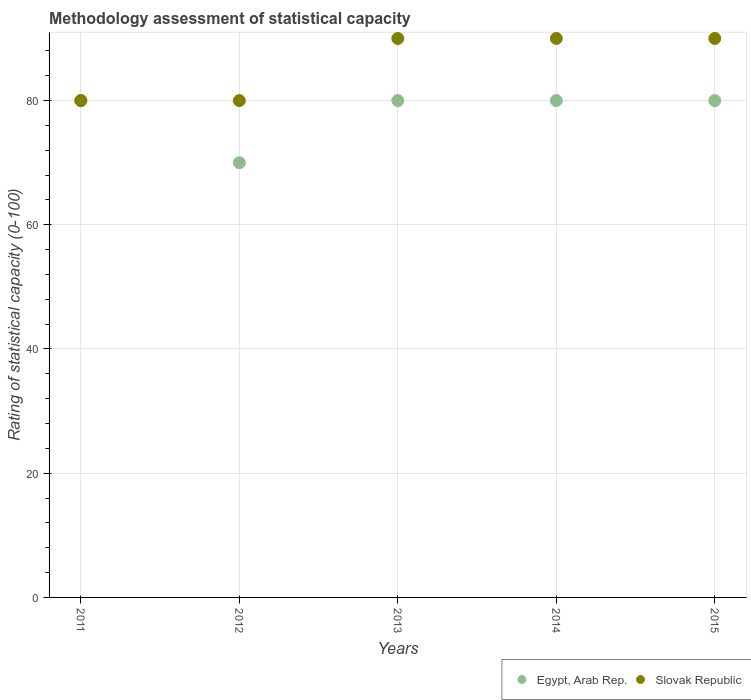What is the rating of statistical capacity in Egypt, Arab Rep. in 2014?
Keep it short and to the point. 80. Across all years, what is the maximum rating of statistical capacity in Egypt, Arab Rep.?
Your answer should be very brief. 80. Across all years, what is the minimum rating of statistical capacity in Slovak Republic?
Give a very brief answer. 80. In which year was the rating of statistical capacity in Egypt, Arab Rep. minimum?
Your response must be concise. 2012. What is the total rating of statistical capacity in Egypt, Arab Rep. in the graph?
Provide a succinct answer. 390. What is the difference between the rating of statistical capacity in Slovak Republic in 2015 and the rating of statistical capacity in Egypt, Arab Rep. in 2013?
Your answer should be very brief. 10. What is the ratio of the rating of statistical capacity in Slovak Republic in 2011 to that in 2015?
Your response must be concise. 0.89. What is the difference between the highest and the second highest rating of statistical capacity in Egypt, Arab Rep.?
Ensure brevity in your answer.  0. What is the difference between the highest and the lowest rating of statistical capacity in Egypt, Arab Rep.?
Your response must be concise. 10. Is the sum of the rating of statistical capacity in Egypt, Arab Rep. in 2013 and 2015 greater than the maximum rating of statistical capacity in Slovak Republic across all years?
Keep it short and to the point. Yes. Does the rating of statistical capacity in Slovak Republic monotonically increase over the years?
Your answer should be very brief. No. What is the difference between two consecutive major ticks on the Y-axis?
Provide a short and direct response. 20. Are the values on the major ticks of Y-axis written in scientific E-notation?
Provide a short and direct response. No. How many legend labels are there?
Your answer should be very brief. 2. How are the legend labels stacked?
Offer a very short reply. Horizontal. What is the title of the graph?
Provide a short and direct response. Methodology assessment of statistical capacity. What is the label or title of the X-axis?
Your answer should be compact. Years. What is the label or title of the Y-axis?
Make the answer very short. Rating of statistical capacity (0-100). What is the Rating of statistical capacity (0-100) of Egypt, Arab Rep. in 2011?
Your answer should be compact. 80. What is the Rating of statistical capacity (0-100) in Slovak Republic in 2011?
Your answer should be very brief. 80. What is the Rating of statistical capacity (0-100) of Egypt, Arab Rep. in 2012?
Provide a succinct answer. 70. What is the Rating of statistical capacity (0-100) in Slovak Republic in 2013?
Your answer should be compact. 90. What is the Rating of statistical capacity (0-100) in Slovak Republic in 2014?
Your response must be concise. 90. Across all years, what is the maximum Rating of statistical capacity (0-100) of Egypt, Arab Rep.?
Offer a terse response. 80. Across all years, what is the minimum Rating of statistical capacity (0-100) in Egypt, Arab Rep.?
Provide a succinct answer. 70. What is the total Rating of statistical capacity (0-100) of Egypt, Arab Rep. in the graph?
Ensure brevity in your answer.  390. What is the total Rating of statistical capacity (0-100) in Slovak Republic in the graph?
Your answer should be compact. 430. What is the difference between the Rating of statistical capacity (0-100) of Egypt, Arab Rep. in 2011 and that in 2013?
Give a very brief answer. 0. What is the difference between the Rating of statistical capacity (0-100) of Slovak Republic in 2011 and that in 2013?
Ensure brevity in your answer.  -10. What is the difference between the Rating of statistical capacity (0-100) in Egypt, Arab Rep. in 2011 and that in 2014?
Offer a very short reply. 0. What is the difference between the Rating of statistical capacity (0-100) in Egypt, Arab Rep. in 2011 and that in 2015?
Your answer should be very brief. 0. What is the difference between the Rating of statistical capacity (0-100) of Slovak Republic in 2011 and that in 2015?
Keep it short and to the point. -10. What is the difference between the Rating of statistical capacity (0-100) of Slovak Republic in 2012 and that in 2014?
Provide a succinct answer. -10. What is the difference between the Rating of statistical capacity (0-100) of Egypt, Arab Rep. in 2012 and that in 2015?
Give a very brief answer. -10. What is the difference between the Rating of statistical capacity (0-100) in Slovak Republic in 2012 and that in 2015?
Keep it short and to the point. -10. What is the difference between the Rating of statistical capacity (0-100) in Egypt, Arab Rep. in 2013 and that in 2014?
Make the answer very short. 0. What is the difference between the Rating of statistical capacity (0-100) of Slovak Republic in 2013 and that in 2014?
Keep it short and to the point. 0. What is the difference between the Rating of statistical capacity (0-100) in Egypt, Arab Rep. in 2013 and that in 2015?
Provide a short and direct response. 0. What is the difference between the Rating of statistical capacity (0-100) in Slovak Republic in 2013 and that in 2015?
Keep it short and to the point. 0. What is the difference between the Rating of statistical capacity (0-100) in Egypt, Arab Rep. in 2014 and that in 2015?
Offer a terse response. 0. What is the difference between the Rating of statistical capacity (0-100) in Slovak Republic in 2014 and that in 2015?
Your response must be concise. 0. What is the difference between the Rating of statistical capacity (0-100) in Egypt, Arab Rep. in 2011 and the Rating of statistical capacity (0-100) in Slovak Republic in 2012?
Your answer should be compact. 0. What is the difference between the Rating of statistical capacity (0-100) of Egypt, Arab Rep. in 2011 and the Rating of statistical capacity (0-100) of Slovak Republic in 2014?
Make the answer very short. -10. What is the difference between the Rating of statistical capacity (0-100) in Egypt, Arab Rep. in 2011 and the Rating of statistical capacity (0-100) in Slovak Republic in 2015?
Provide a short and direct response. -10. What is the difference between the Rating of statistical capacity (0-100) in Egypt, Arab Rep. in 2012 and the Rating of statistical capacity (0-100) in Slovak Republic in 2013?
Ensure brevity in your answer.  -20. What is the difference between the Rating of statistical capacity (0-100) of Egypt, Arab Rep. in 2012 and the Rating of statistical capacity (0-100) of Slovak Republic in 2014?
Provide a succinct answer. -20. What is the difference between the Rating of statistical capacity (0-100) of Egypt, Arab Rep. in 2014 and the Rating of statistical capacity (0-100) of Slovak Republic in 2015?
Your answer should be compact. -10. In the year 2012, what is the difference between the Rating of statistical capacity (0-100) in Egypt, Arab Rep. and Rating of statistical capacity (0-100) in Slovak Republic?
Provide a succinct answer. -10. In the year 2013, what is the difference between the Rating of statistical capacity (0-100) of Egypt, Arab Rep. and Rating of statistical capacity (0-100) of Slovak Republic?
Provide a succinct answer. -10. What is the ratio of the Rating of statistical capacity (0-100) in Egypt, Arab Rep. in 2011 to that in 2012?
Keep it short and to the point. 1.14. What is the ratio of the Rating of statistical capacity (0-100) in Egypt, Arab Rep. in 2011 to that in 2013?
Provide a succinct answer. 1. What is the ratio of the Rating of statistical capacity (0-100) in Egypt, Arab Rep. in 2011 to that in 2014?
Make the answer very short. 1. What is the ratio of the Rating of statistical capacity (0-100) of Egypt, Arab Rep. in 2011 to that in 2015?
Provide a short and direct response. 1. What is the ratio of the Rating of statistical capacity (0-100) in Egypt, Arab Rep. in 2012 to that in 2013?
Provide a short and direct response. 0.88. What is the ratio of the Rating of statistical capacity (0-100) of Egypt, Arab Rep. in 2012 to that in 2014?
Keep it short and to the point. 0.88. What is the ratio of the Rating of statistical capacity (0-100) in Slovak Republic in 2012 to that in 2015?
Provide a short and direct response. 0.89. What is the ratio of the Rating of statistical capacity (0-100) in Egypt, Arab Rep. in 2014 to that in 2015?
Make the answer very short. 1. What is the ratio of the Rating of statistical capacity (0-100) in Slovak Republic in 2014 to that in 2015?
Make the answer very short. 1. What is the difference between the highest and the second highest Rating of statistical capacity (0-100) of Slovak Republic?
Provide a short and direct response. 0. What is the difference between the highest and the lowest Rating of statistical capacity (0-100) in Slovak Republic?
Your answer should be compact. 10. 